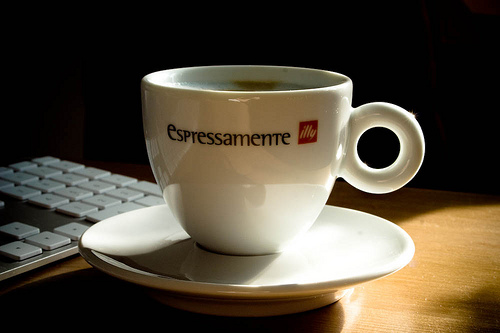Read and extract the text from this image. espressamenre illy 